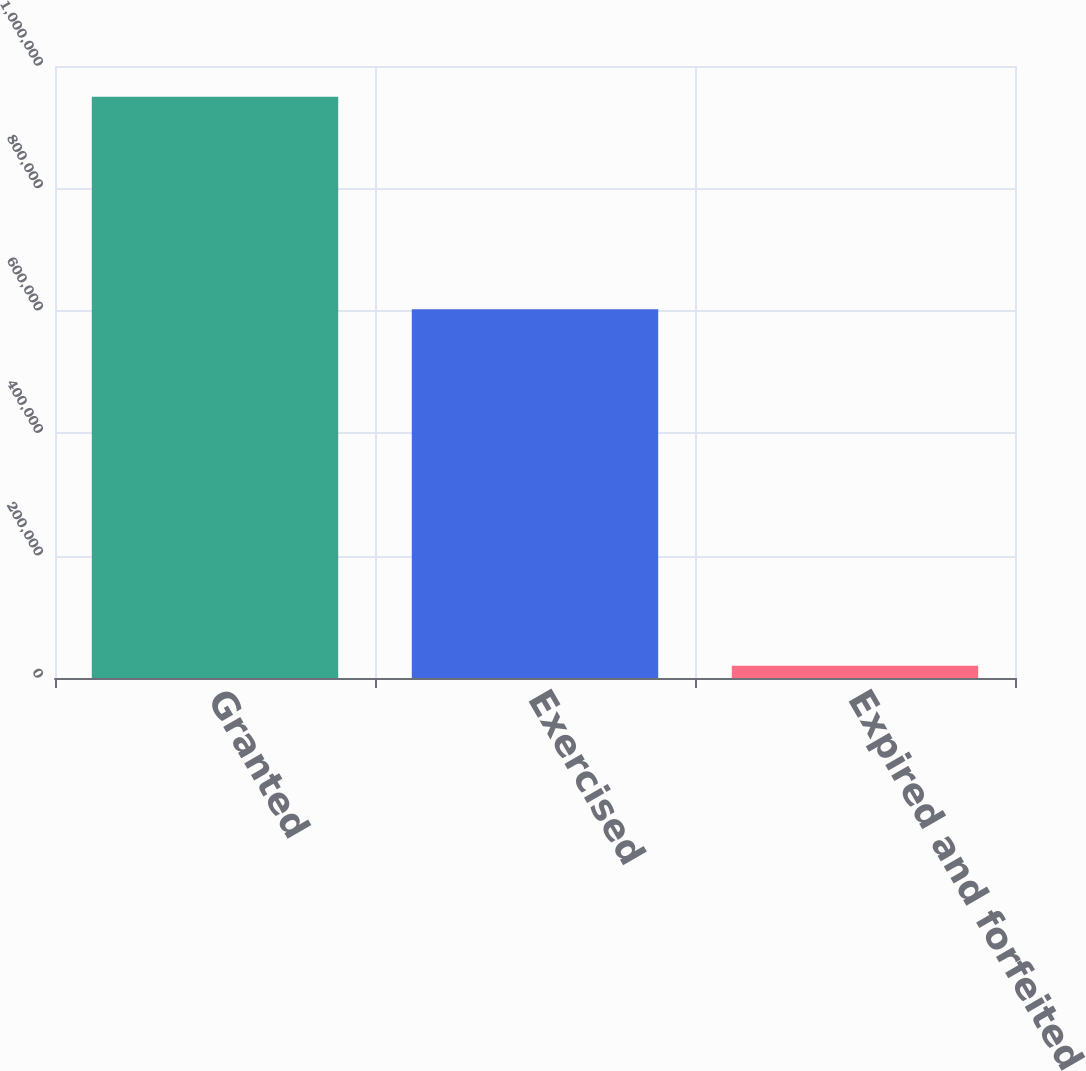<chart> <loc_0><loc_0><loc_500><loc_500><bar_chart><fcel>Granted<fcel>Exercised<fcel>Expired and forfeited<nl><fcel>949750<fcel>602550<fcel>20146<nl></chart> 